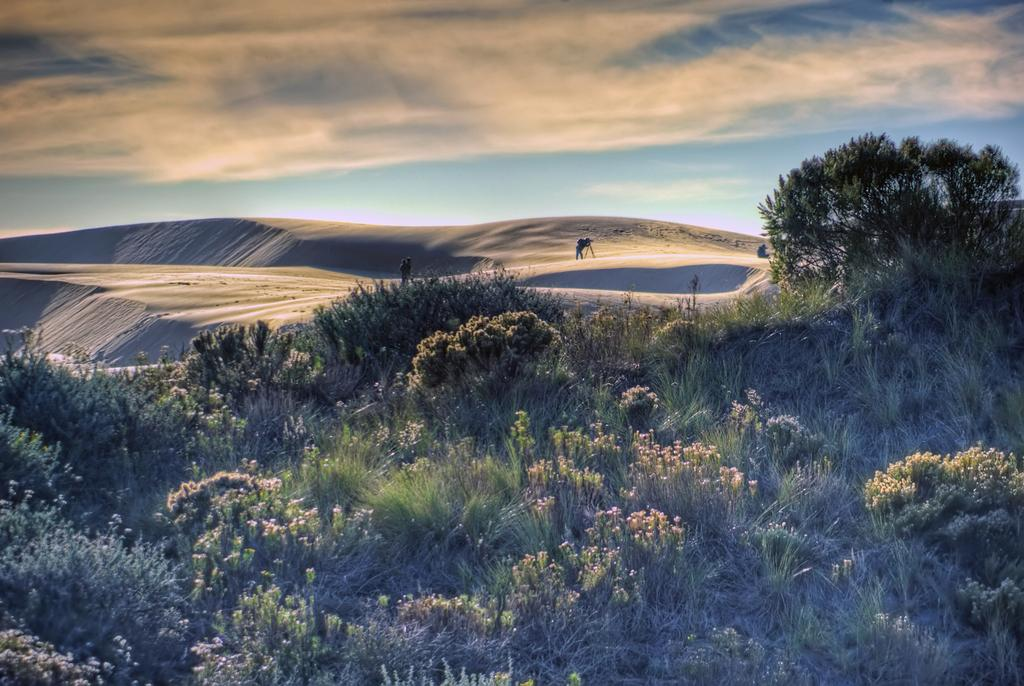What can be seen in the sky in the image? The sky with clouds is visible in the image. What type of landscape is present in the image? There is a desert in the image. What type of vegetation is present in the image? There are trees in the image. What are the persons in the image doing? The persons are on the sand in the image. How many balls can be seen in the image? There are no balls present in the image. How long does it take for the minute to pass in the image? The concept of time passing is not visible in the image, so it cannot be determined. 